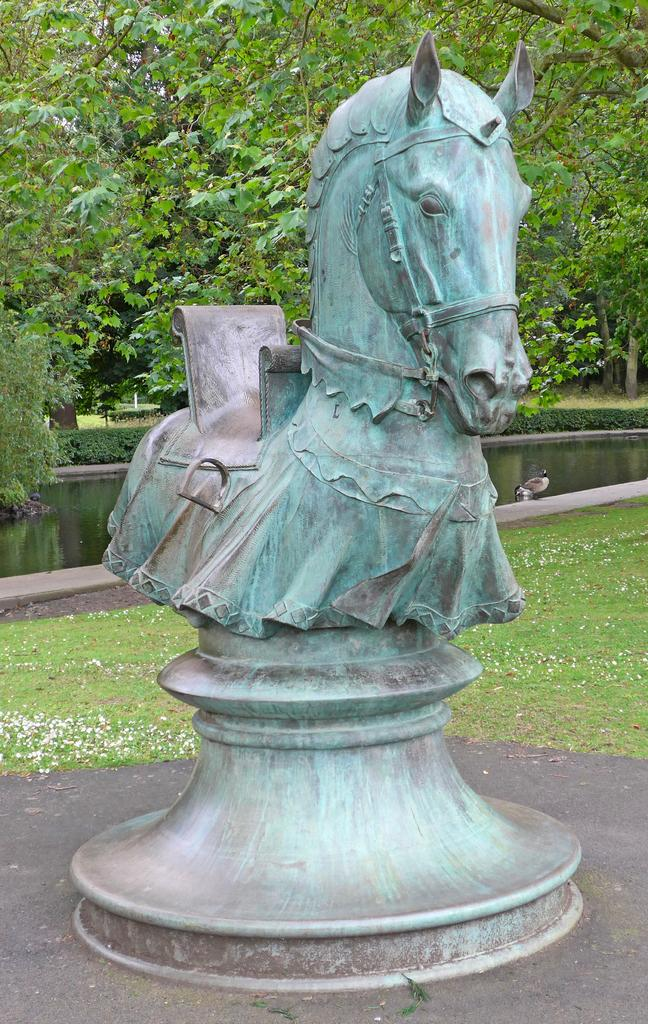What is the main subject in the center of the image? There is a sculpture in the center of the image. What type of natural elements can be seen in the image? There are trees in the image. What can be seen in the background of the image? There is a pond and a bird visible in the background of the image. How many spiders are crawling on the sculpture in the image? There are no spiders visible on the sculpture in the image. What type of fowl can be seen in the image? There is no specific type of fowl mentioned in the image; only a bird is mentioned in the background. 